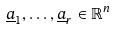<formula> <loc_0><loc_0><loc_500><loc_500>\underline { a } _ { 1 } , \dots , \underline { a } _ { r } \in \mathbb { R } ^ { n }</formula> 